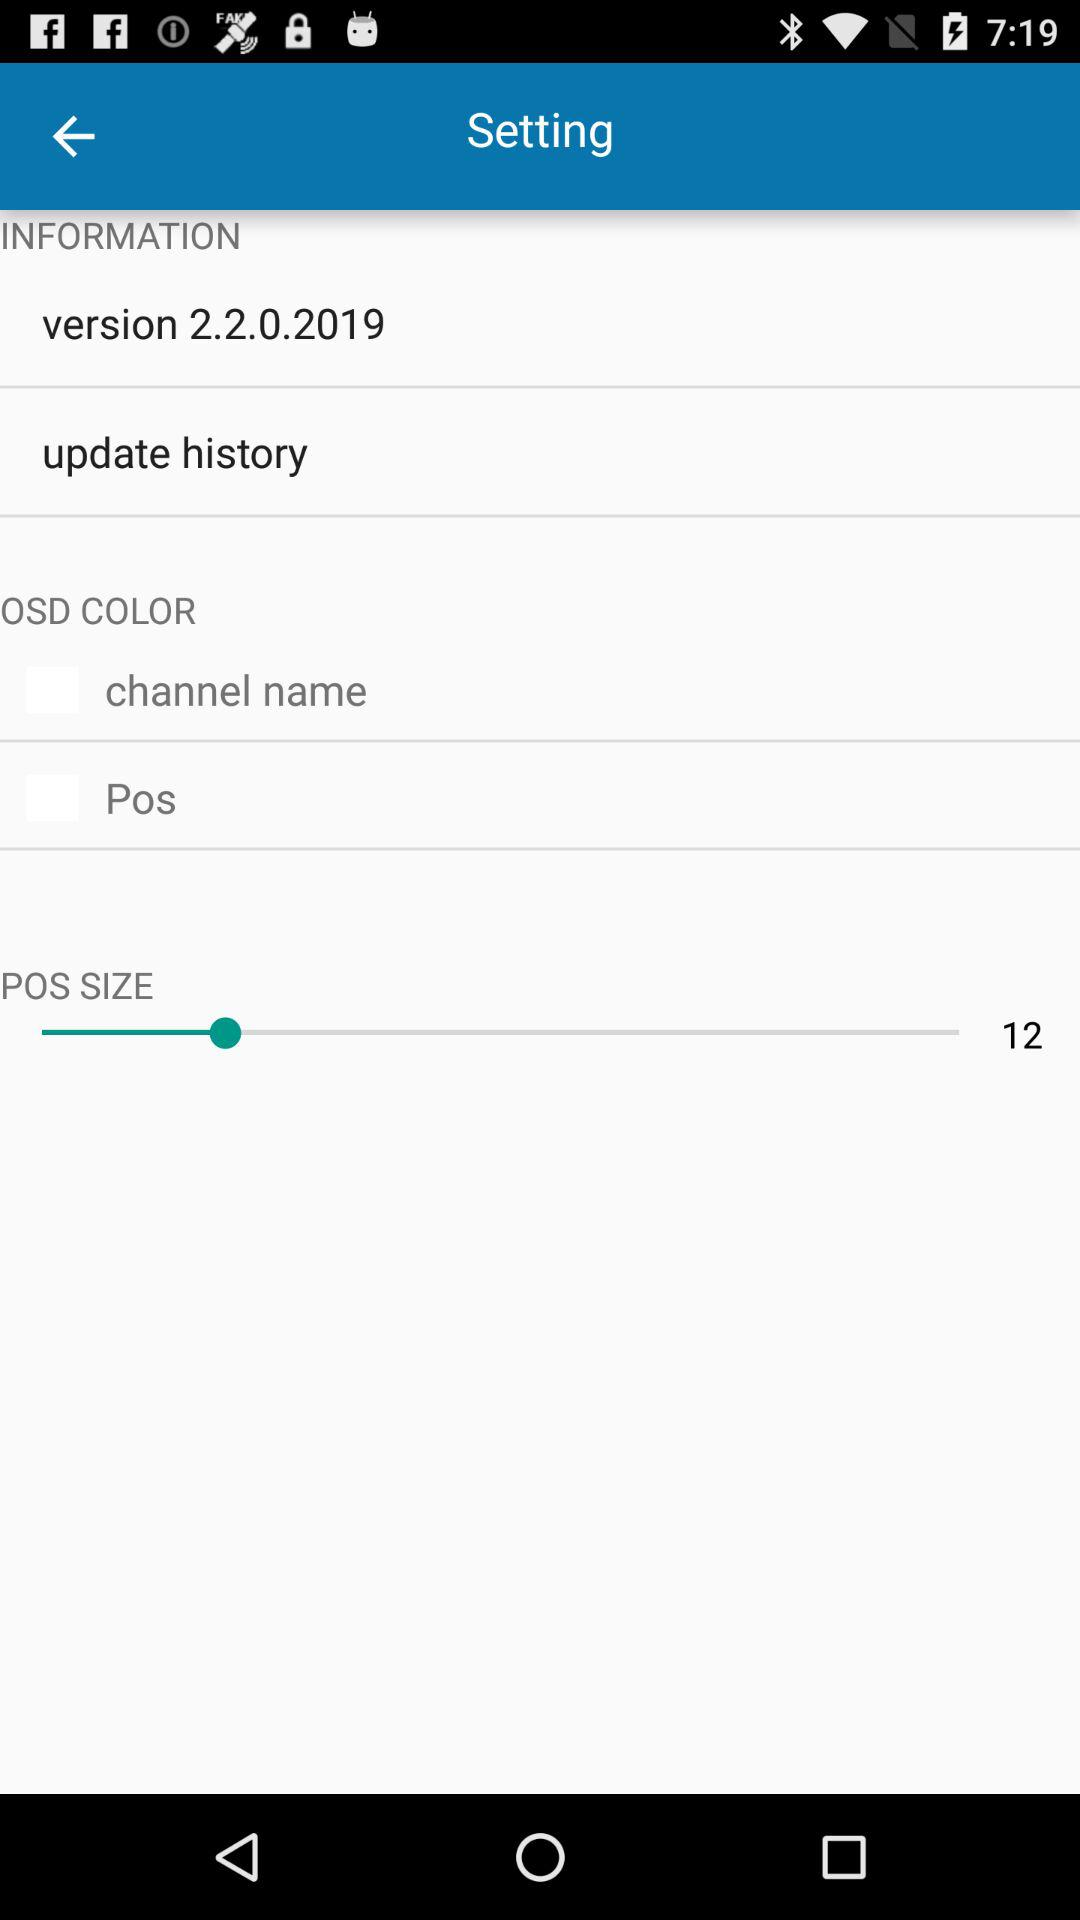What is the current status of Pos? The current status is "off". 